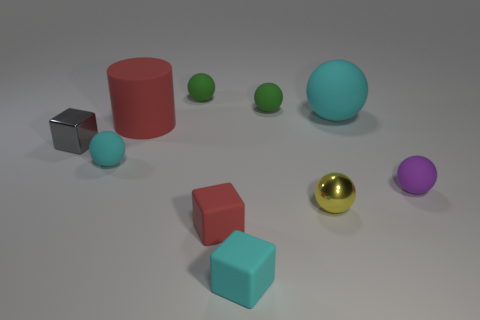What time of day does the lighting in the scene suggest? The soft shadows and diffused light in the image suggest an indoor setting with artificial lighting rather than natural daylight, making it challenging to determine a specific time of day. 